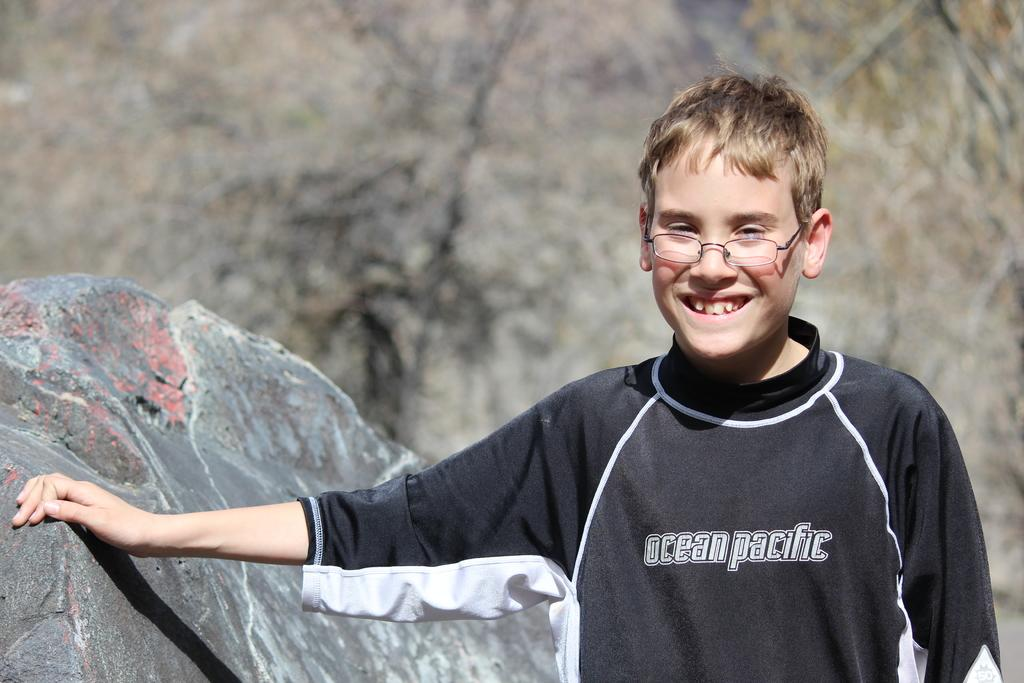<image>
Render a clear and concise summary of the photo. A teen with glasses leaning against a rock and wearing an Ocean Pacific black shirt. 